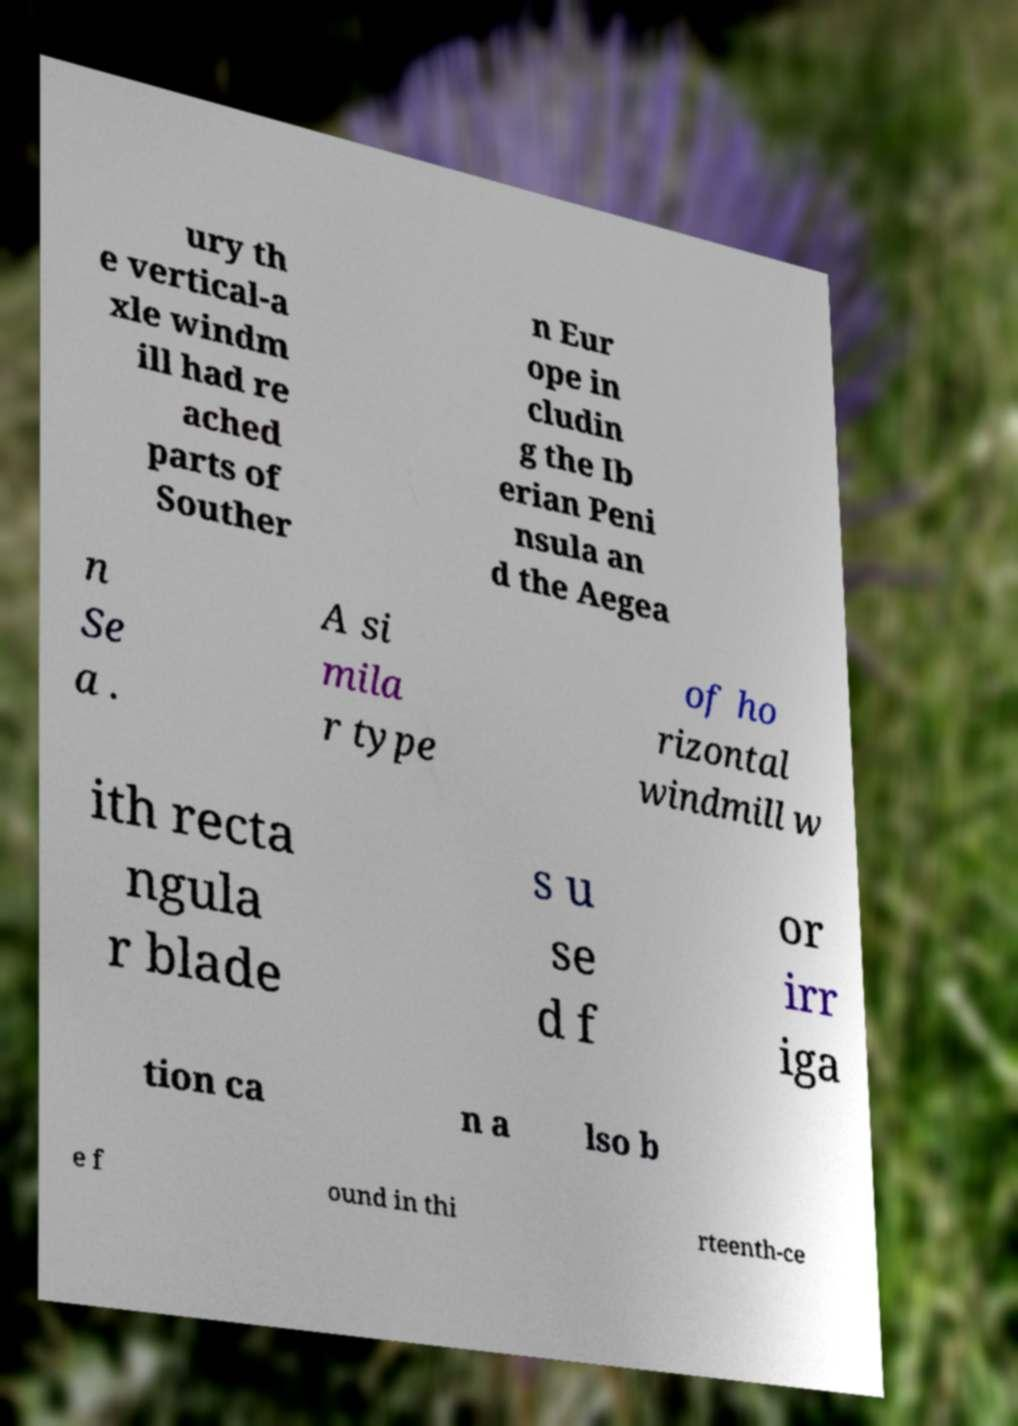There's text embedded in this image that I need extracted. Can you transcribe it verbatim? ury th e vertical-a xle windm ill had re ached parts of Souther n Eur ope in cludin g the Ib erian Peni nsula an d the Aegea n Se a . A si mila r type of ho rizontal windmill w ith recta ngula r blade s u se d f or irr iga tion ca n a lso b e f ound in thi rteenth-ce 